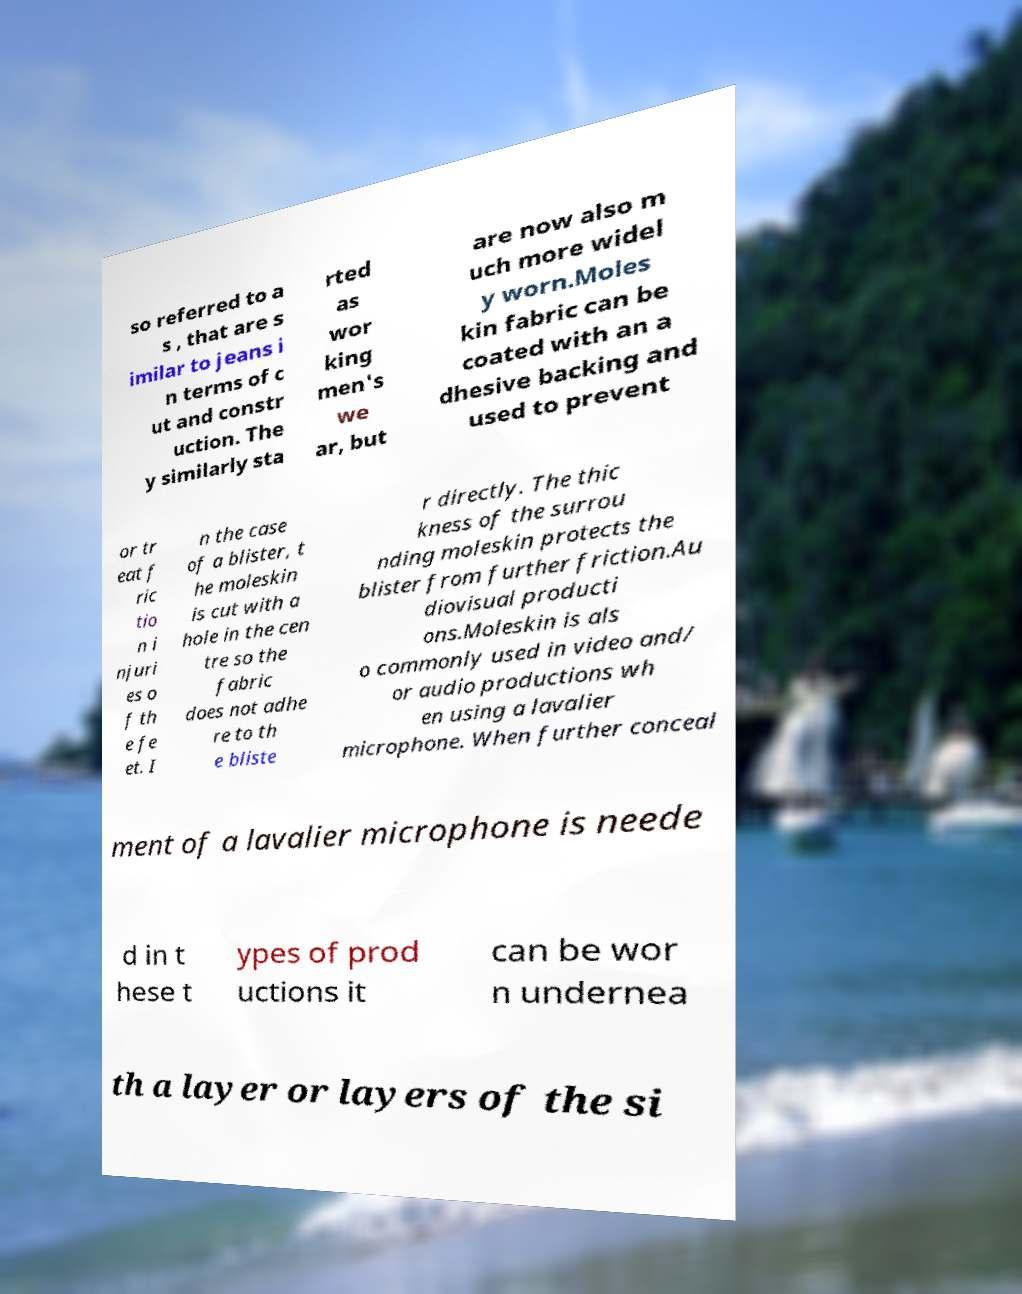Could you extract and type out the text from this image? so referred to a s , that are s imilar to jeans i n terms of c ut and constr uction. The y similarly sta rted as wor king men's we ar, but are now also m uch more widel y worn.Moles kin fabric can be coated with an a dhesive backing and used to prevent or tr eat f ric tio n i njuri es o f th e fe et. I n the case of a blister, t he moleskin is cut with a hole in the cen tre so the fabric does not adhe re to th e bliste r directly. The thic kness of the surrou nding moleskin protects the blister from further friction.Au diovisual producti ons.Moleskin is als o commonly used in video and/ or audio productions wh en using a lavalier microphone. When further conceal ment of a lavalier microphone is neede d in t hese t ypes of prod uctions it can be wor n undernea th a layer or layers of the si 